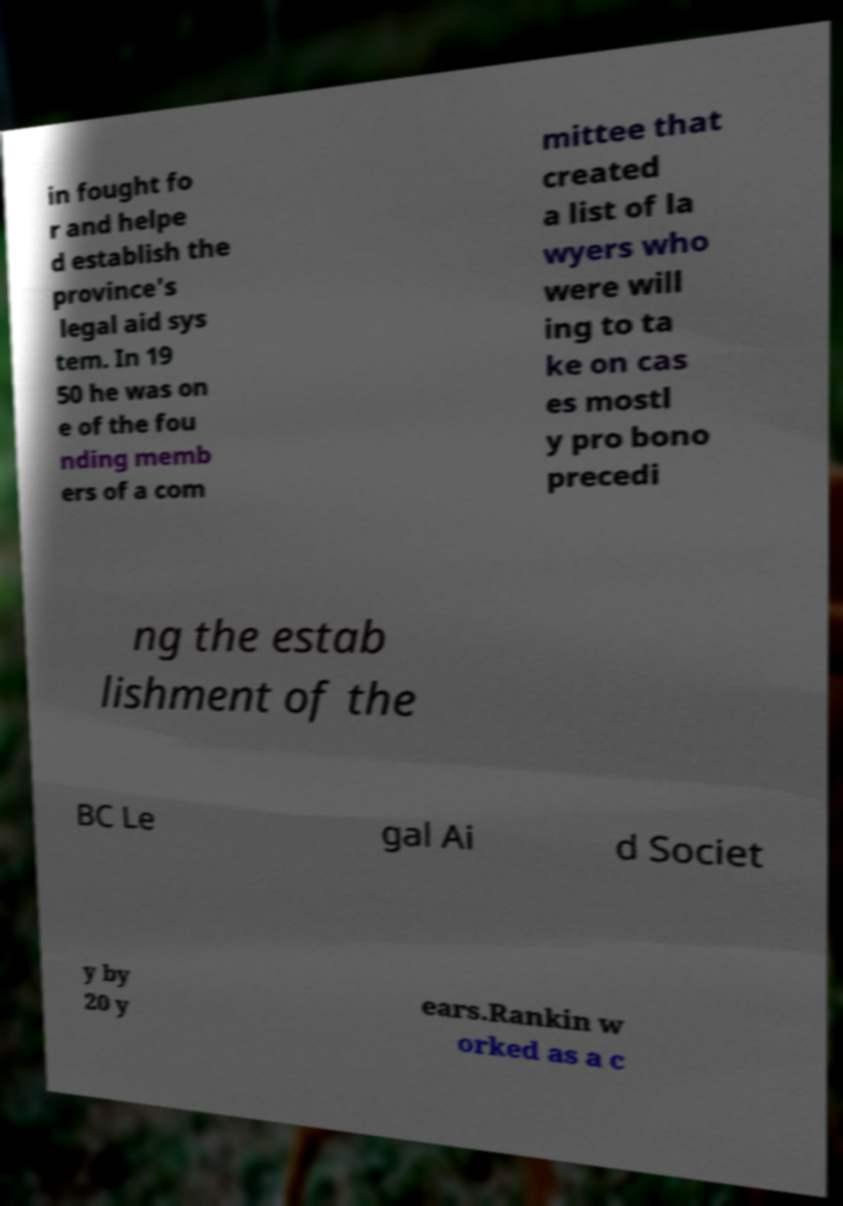Could you extract and type out the text from this image? in fought fo r and helpe d establish the province's legal aid sys tem. In 19 50 he was on e of the fou nding memb ers of a com mittee that created a list of la wyers who were will ing to ta ke on cas es mostl y pro bono precedi ng the estab lishment of the BC Le gal Ai d Societ y by 20 y ears.Rankin w orked as a c 